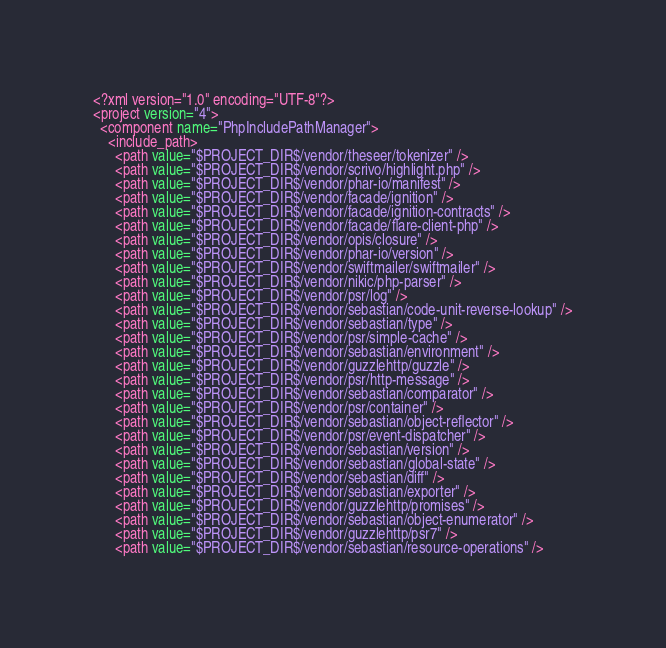<code> <loc_0><loc_0><loc_500><loc_500><_XML_><?xml version="1.0" encoding="UTF-8"?>
<project version="4">
  <component name="PhpIncludePathManager">
    <include_path>
      <path value="$PROJECT_DIR$/vendor/theseer/tokenizer" />
      <path value="$PROJECT_DIR$/vendor/scrivo/highlight.php" />
      <path value="$PROJECT_DIR$/vendor/phar-io/manifest" />
      <path value="$PROJECT_DIR$/vendor/facade/ignition" />
      <path value="$PROJECT_DIR$/vendor/facade/ignition-contracts" />
      <path value="$PROJECT_DIR$/vendor/facade/flare-client-php" />
      <path value="$PROJECT_DIR$/vendor/opis/closure" />
      <path value="$PROJECT_DIR$/vendor/phar-io/version" />
      <path value="$PROJECT_DIR$/vendor/swiftmailer/swiftmailer" />
      <path value="$PROJECT_DIR$/vendor/nikic/php-parser" />
      <path value="$PROJECT_DIR$/vendor/psr/log" />
      <path value="$PROJECT_DIR$/vendor/sebastian/code-unit-reverse-lookup" />
      <path value="$PROJECT_DIR$/vendor/sebastian/type" />
      <path value="$PROJECT_DIR$/vendor/psr/simple-cache" />
      <path value="$PROJECT_DIR$/vendor/sebastian/environment" />
      <path value="$PROJECT_DIR$/vendor/guzzlehttp/guzzle" />
      <path value="$PROJECT_DIR$/vendor/psr/http-message" />
      <path value="$PROJECT_DIR$/vendor/sebastian/comparator" />
      <path value="$PROJECT_DIR$/vendor/psr/container" />
      <path value="$PROJECT_DIR$/vendor/sebastian/object-reflector" />
      <path value="$PROJECT_DIR$/vendor/psr/event-dispatcher" />
      <path value="$PROJECT_DIR$/vendor/sebastian/version" />
      <path value="$PROJECT_DIR$/vendor/sebastian/global-state" />
      <path value="$PROJECT_DIR$/vendor/sebastian/diff" />
      <path value="$PROJECT_DIR$/vendor/sebastian/exporter" />
      <path value="$PROJECT_DIR$/vendor/guzzlehttp/promises" />
      <path value="$PROJECT_DIR$/vendor/sebastian/object-enumerator" />
      <path value="$PROJECT_DIR$/vendor/guzzlehttp/psr7" />
      <path value="$PROJECT_DIR$/vendor/sebastian/resource-operations" /></code> 